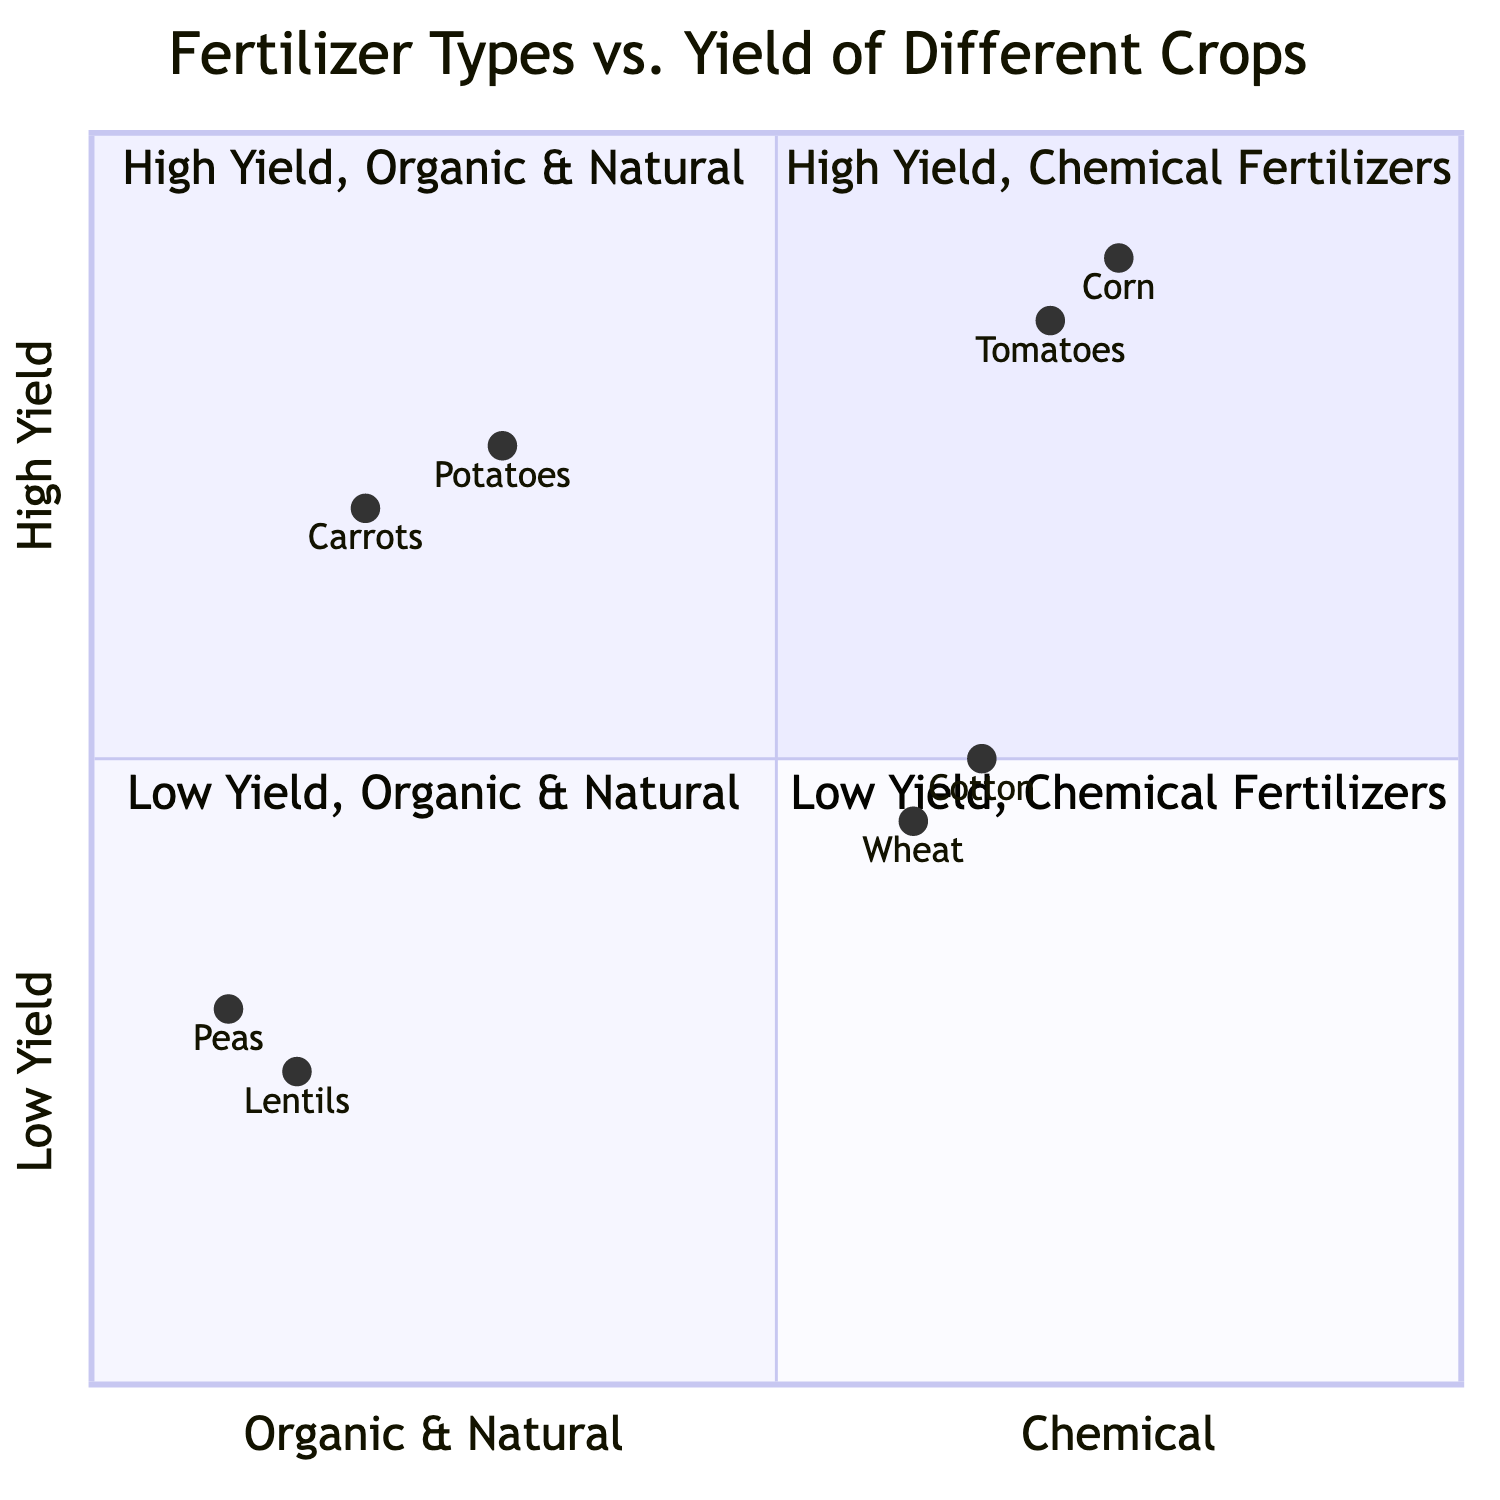What is the highest yield crop using chemical fertilizers? According to the quadrant titled "High Yield, High Fertilizer Use," the crop with the highest yield using chemical fertilizers is Corn, which has a yield of 9 tons per acre.
Answer: Corn Which crops have high yields but low fertilizer use? In the quadrant labeled "High Yield, Low Fertilizer Use," the crops listed are Carrots with a yield of 7 tons per acre and Potatoes with a yield of 7.5 tons per acre, indicating that both these crops can achieve high yields without much reliance on fertilizers.
Answer: Carrots, Potatoes What is the yield of peas with green manure? Within the "Low Yield, Low Fertilizer Use" quadrant, Peas are shown to have a yield of 3 tons per acre when grown with green manure.
Answer: 3 How many crops have low yields and use chemical fertilizers? The "Low Yield, High Fertilizer Use" quadrant lists 2 crops: Wheat (4.5 tons per acre) and Cotton (5 tons per acre). Therefore, there are two crops that fall into this category.
Answer: 2 Which fertilizer type is associated with the highest yield in the diagram? The quadrant "High Yield, High Fertilizer Use" indicates that Chemical Fertilizers are associated with the highest yields, as evidenced by Corn and Tomatoes having yields of 9 and 8.5 tons per acre, respectively.
Answer: Chemical Fertilizers What is the yield difference between carrots and potatoes? Carrots yield 7 tons per acre and Potatoes yield 7.5 tons per acre. The difference in yield between them is calculated by subtracting Carrots (7) from Potatoes (7.5), resulting in a difference of 0.5 tons per acre.
Answer: 0.5 What quadrant contains lentils? Lentils are located in the "Low Yield, Low Fertilizer Use" quadrant, which indicates they have both low yield and low fertilizer application.
Answer: Low Yield, Low Fertilizer Use Which type of fertilizers is used for corn? In the "High Yield, High Fertilizer Use" quadrant, it states that Corn is grown using Chemical Fertilizers, which help achieve its high yield.
Answer: Chemical Fertilizers 